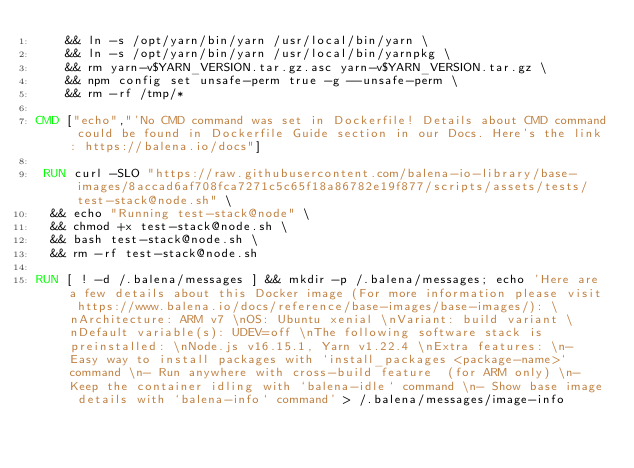<code> <loc_0><loc_0><loc_500><loc_500><_Dockerfile_>	&& ln -s /opt/yarn/bin/yarn /usr/local/bin/yarn \
	&& ln -s /opt/yarn/bin/yarn /usr/local/bin/yarnpkg \
	&& rm yarn-v$YARN_VERSION.tar.gz.asc yarn-v$YARN_VERSION.tar.gz \
	&& npm config set unsafe-perm true -g --unsafe-perm \
	&& rm -rf /tmp/*

CMD ["echo","'No CMD command was set in Dockerfile! Details about CMD command could be found in Dockerfile Guide section in our Docs. Here's the link: https://balena.io/docs"]

 RUN curl -SLO "https://raw.githubusercontent.com/balena-io-library/base-images/8accad6af708fca7271c5c65f18a86782e19f877/scripts/assets/tests/test-stack@node.sh" \
  && echo "Running test-stack@node" \
  && chmod +x test-stack@node.sh \
  && bash test-stack@node.sh \
  && rm -rf test-stack@node.sh 

RUN [ ! -d /.balena/messages ] && mkdir -p /.balena/messages; echo 'Here are a few details about this Docker image (For more information please visit https://www.balena.io/docs/reference/base-images/base-images/): \nArchitecture: ARM v7 \nOS: Ubuntu xenial \nVariant: build variant \nDefault variable(s): UDEV=off \nThe following software stack is preinstalled: \nNode.js v16.15.1, Yarn v1.22.4 \nExtra features: \n- Easy way to install packages with `install_packages <package-name>` command \n- Run anywhere with cross-build feature  (for ARM only) \n- Keep the container idling with `balena-idle` command \n- Show base image details with `balena-info` command' > /.balena/messages/image-info</code> 